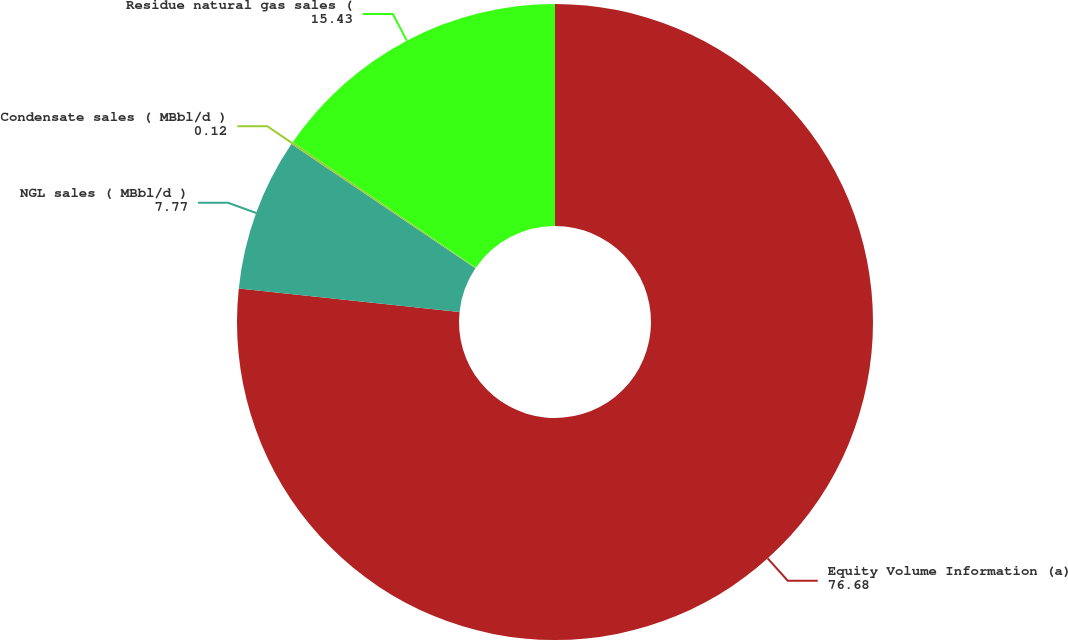<chart> <loc_0><loc_0><loc_500><loc_500><pie_chart><fcel>Equity Volume Information (a)<fcel>NGL sales ( MBbl/d )<fcel>Condensate sales ( MBbl/d )<fcel>Residue natural gas sales (<nl><fcel>76.68%<fcel>7.77%<fcel>0.12%<fcel>15.43%<nl></chart> 